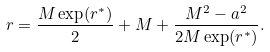Convert formula to latex. <formula><loc_0><loc_0><loc_500><loc_500>r = \frac { M \exp ( r ^ { * } ) } { 2 } + M + \frac { M ^ { 2 } - a ^ { 2 } } { 2 M \exp ( r ^ { * } ) } .</formula> 